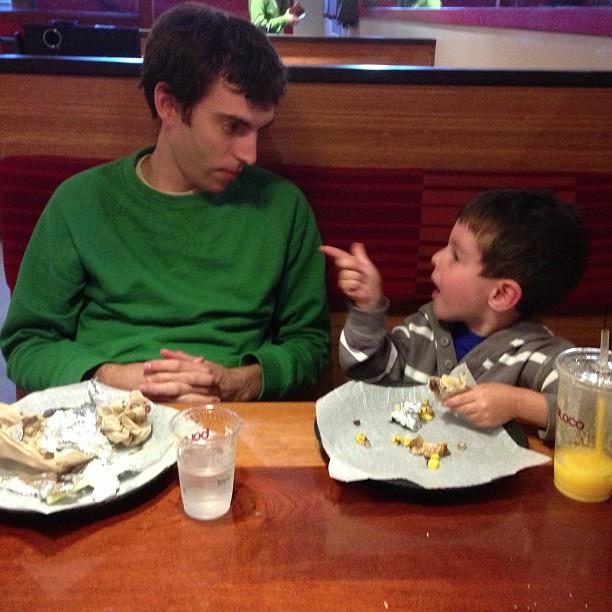What is on the boy's plate?
Answer briefly. Food. What is on his plate?
Quick response, please. Food. What is the man holding?
Be succinct. Nothing. Where is the man sitting?
Short answer required. Bench. Is the child talking to the man?
Give a very brief answer. Yes. What ethnicity are they?
Be succinct. White. What is this guy doing?
Quick response, please. Listening. What color is the man's shirt?
Write a very short answer. Green. What is the man drinking?
Keep it brief. Water. 